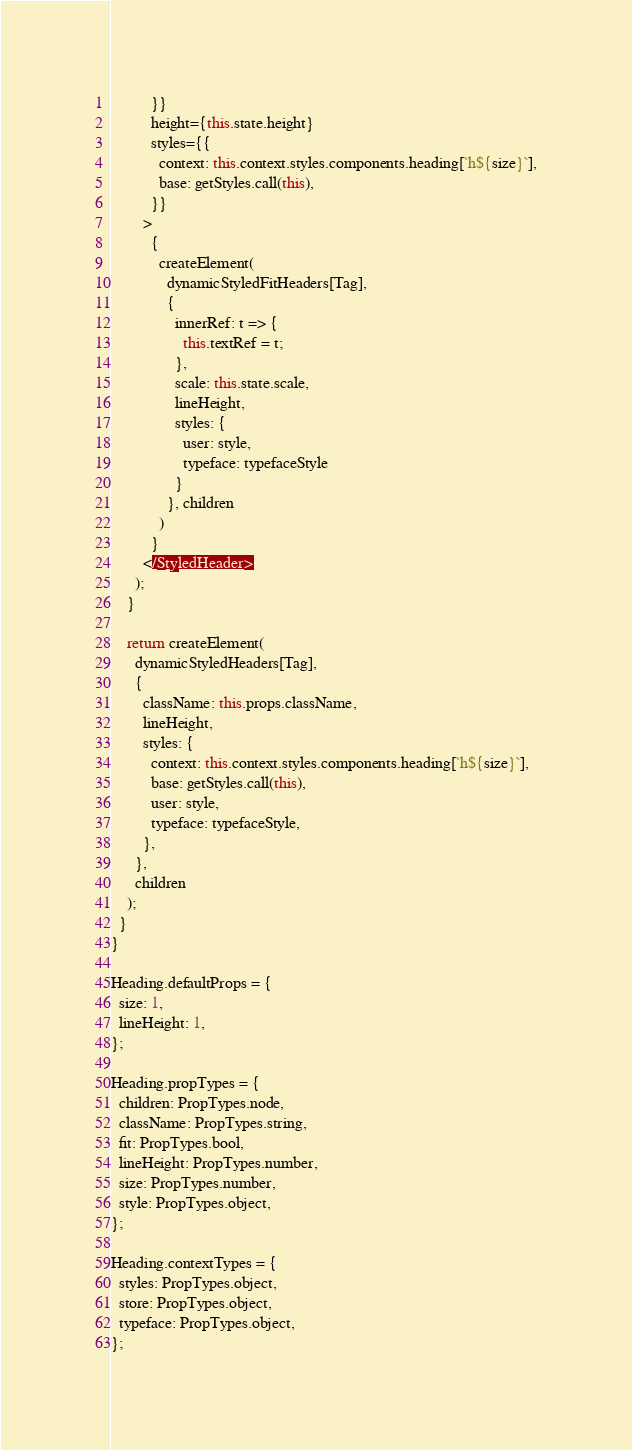<code> <loc_0><loc_0><loc_500><loc_500><_JavaScript_>          }}
          height={this.state.height}
          styles={{
            context: this.context.styles.components.heading[`h${size}`],
            base: getStyles.call(this),
          }}
        >
          {
            createElement(
              dynamicStyledFitHeaders[Tag],
              {
                innerRef: t => {
                  this.textRef = t;
                },
                scale: this.state.scale,
                lineHeight,
                styles: {
                  user: style,
                  typeface: typefaceStyle
                }
              }, children
            )
          }
        </StyledHeader>
      );
    }

    return createElement(
      dynamicStyledHeaders[Tag],
      {
        className: this.props.className,
        lineHeight,
        styles: {
          context: this.context.styles.components.heading[`h${size}`],
          base: getStyles.call(this),
          user: style,
          typeface: typefaceStyle,
        },
      },
      children
    );
  }
}

Heading.defaultProps = {
  size: 1,
  lineHeight: 1,
};

Heading.propTypes = {
  children: PropTypes.node,
  className: PropTypes.string,
  fit: PropTypes.bool,
  lineHeight: PropTypes.number,
  size: PropTypes.number,
  style: PropTypes.object,
};

Heading.contextTypes = {
  styles: PropTypes.object,
  store: PropTypes.object,
  typeface: PropTypes.object,
};
</code> 